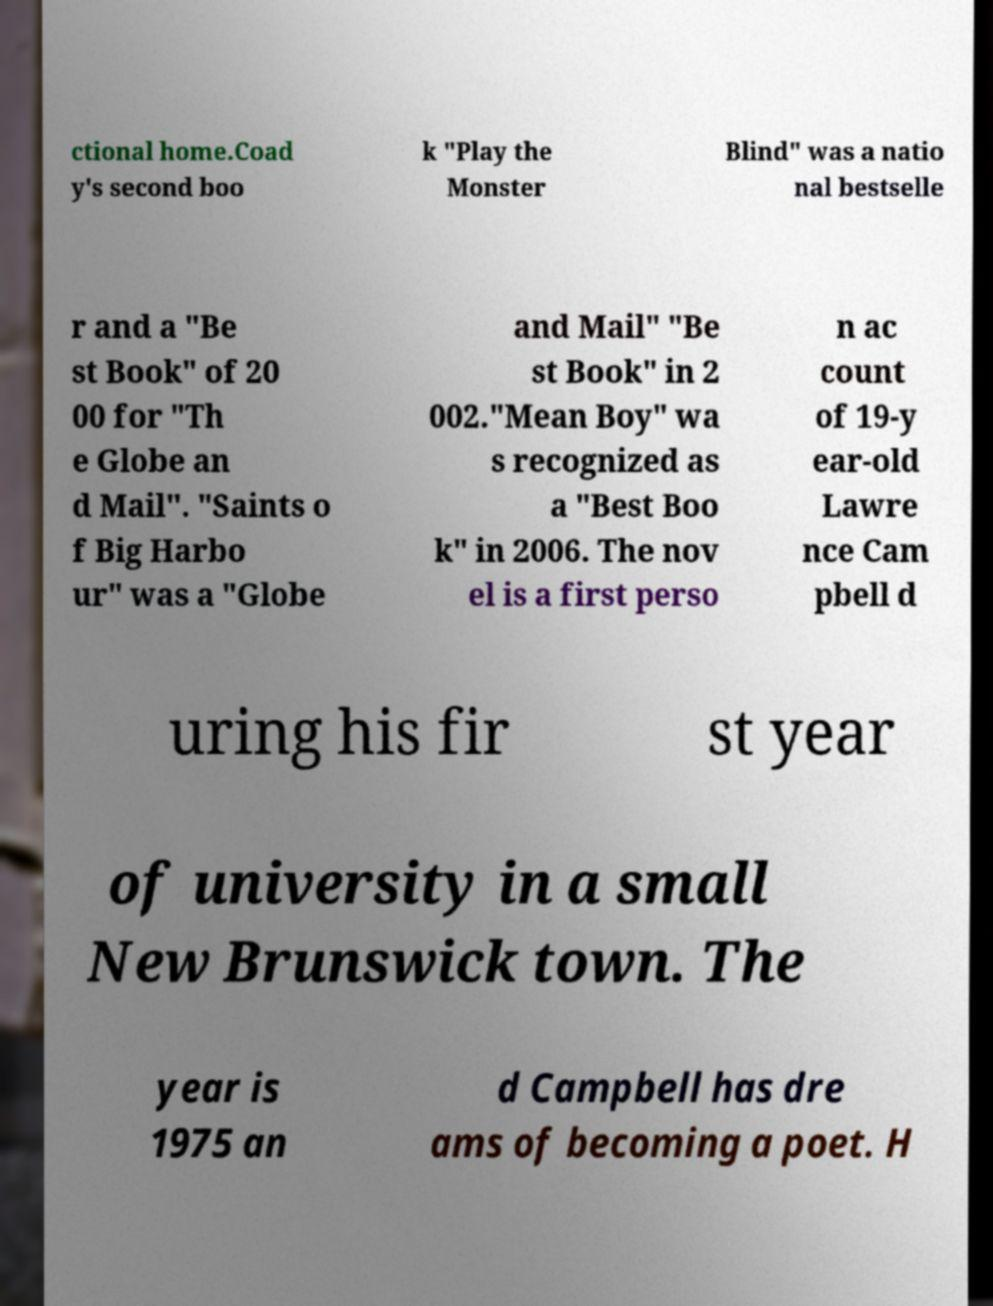Can you read and provide the text displayed in the image?This photo seems to have some interesting text. Can you extract and type it out for me? ctional home.Coad y's second boo k "Play the Monster Blind" was a natio nal bestselle r and a "Be st Book" of 20 00 for "Th e Globe an d Mail". "Saints o f Big Harbo ur" was a "Globe and Mail" "Be st Book" in 2 002."Mean Boy" wa s recognized as a "Best Boo k" in 2006. The nov el is a first perso n ac count of 19-y ear-old Lawre nce Cam pbell d uring his fir st year of university in a small New Brunswick town. The year is 1975 an d Campbell has dre ams of becoming a poet. H 